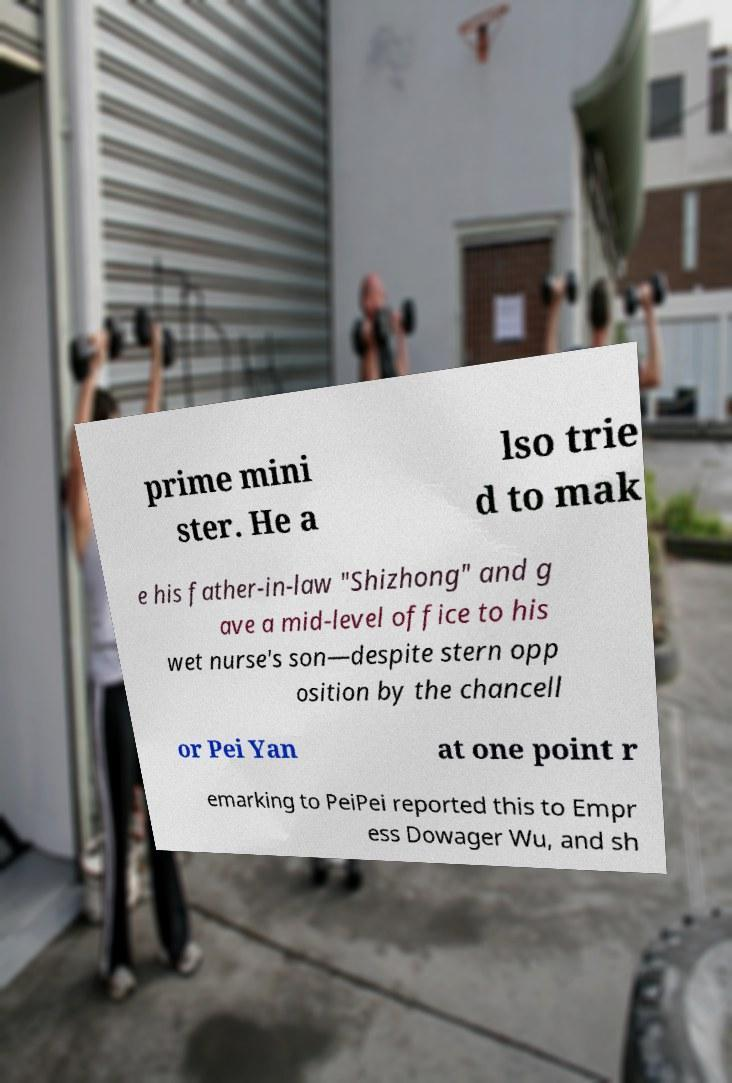What messages or text are displayed in this image? I need them in a readable, typed format. prime mini ster. He a lso trie d to mak e his father-in-law "Shizhong" and g ave a mid-level office to his wet nurse's son—despite stern opp osition by the chancell or Pei Yan at one point r emarking to PeiPei reported this to Empr ess Dowager Wu, and sh 